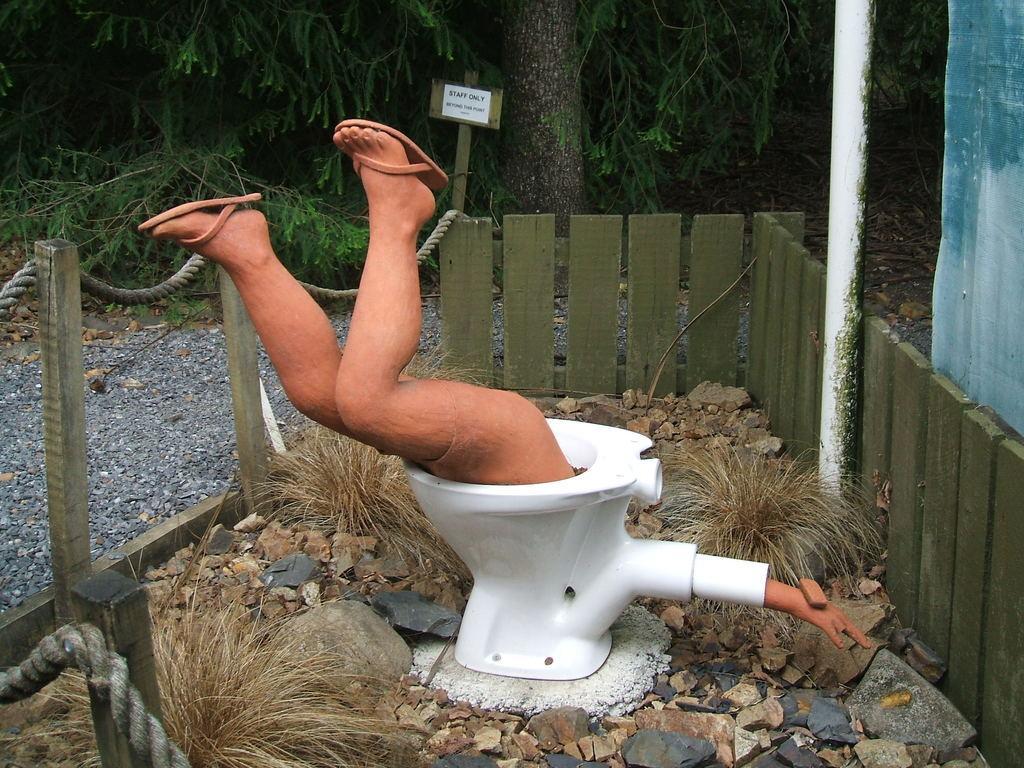How would you summarize this image in a sentence or two? In this image I can see a person body inside the toilet, background I can see a fencing and trees in green color and I can see a board attached to the wooden stick. 